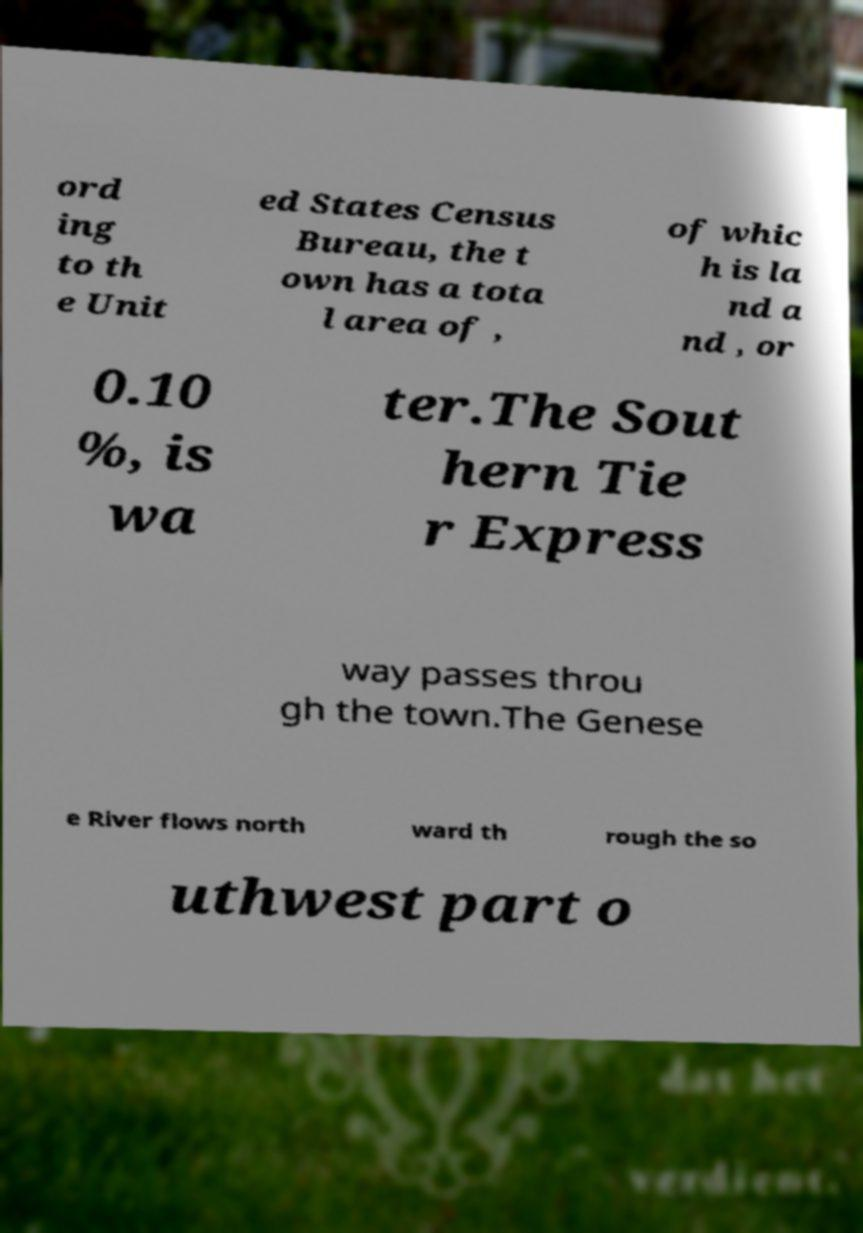Can you read and provide the text displayed in the image?This photo seems to have some interesting text. Can you extract and type it out for me? ord ing to th e Unit ed States Census Bureau, the t own has a tota l area of , of whic h is la nd a nd , or 0.10 %, is wa ter.The Sout hern Tie r Express way passes throu gh the town.The Genese e River flows north ward th rough the so uthwest part o 